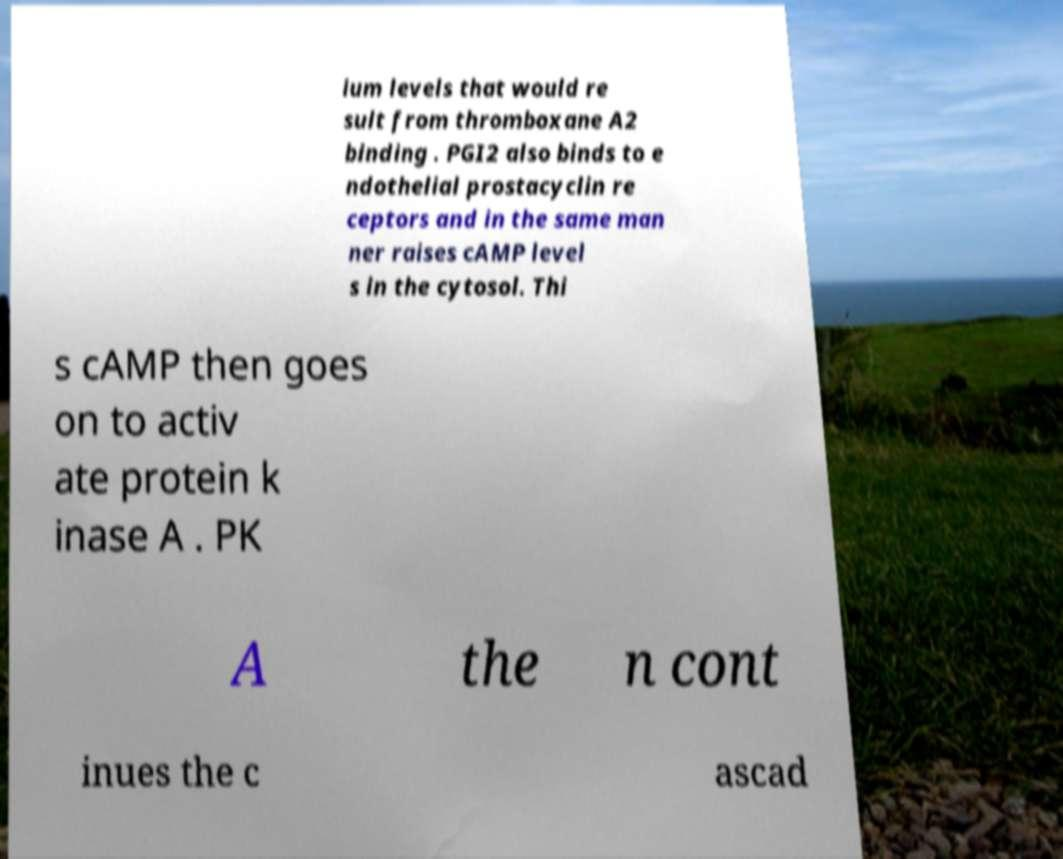What messages or text are displayed in this image? I need them in a readable, typed format. ium levels that would re sult from thromboxane A2 binding . PGI2 also binds to e ndothelial prostacyclin re ceptors and in the same man ner raises cAMP level s in the cytosol. Thi s cAMP then goes on to activ ate protein k inase A . PK A the n cont inues the c ascad 